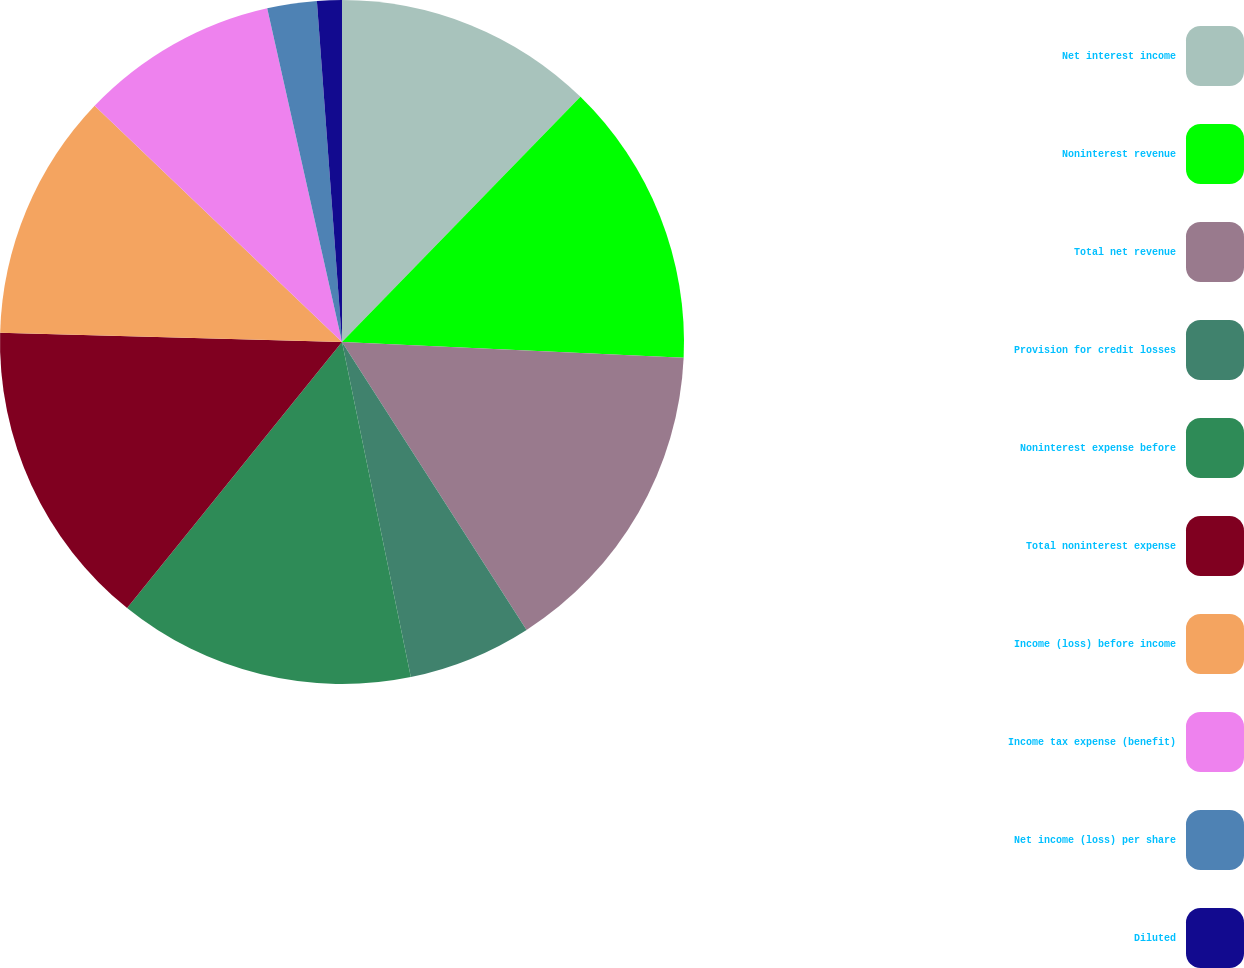Convert chart. <chart><loc_0><loc_0><loc_500><loc_500><pie_chart><fcel>Net interest income<fcel>Noninterest revenue<fcel>Total net revenue<fcel>Provision for credit losses<fcel>Noninterest expense before<fcel>Total noninterest expense<fcel>Income (loss) before income<fcel>Income tax expense (benefit)<fcel>Net income (loss) per share<fcel>Diluted<nl><fcel>12.28%<fcel>13.45%<fcel>15.2%<fcel>5.85%<fcel>14.04%<fcel>14.62%<fcel>11.7%<fcel>9.36%<fcel>2.34%<fcel>1.17%<nl></chart> 